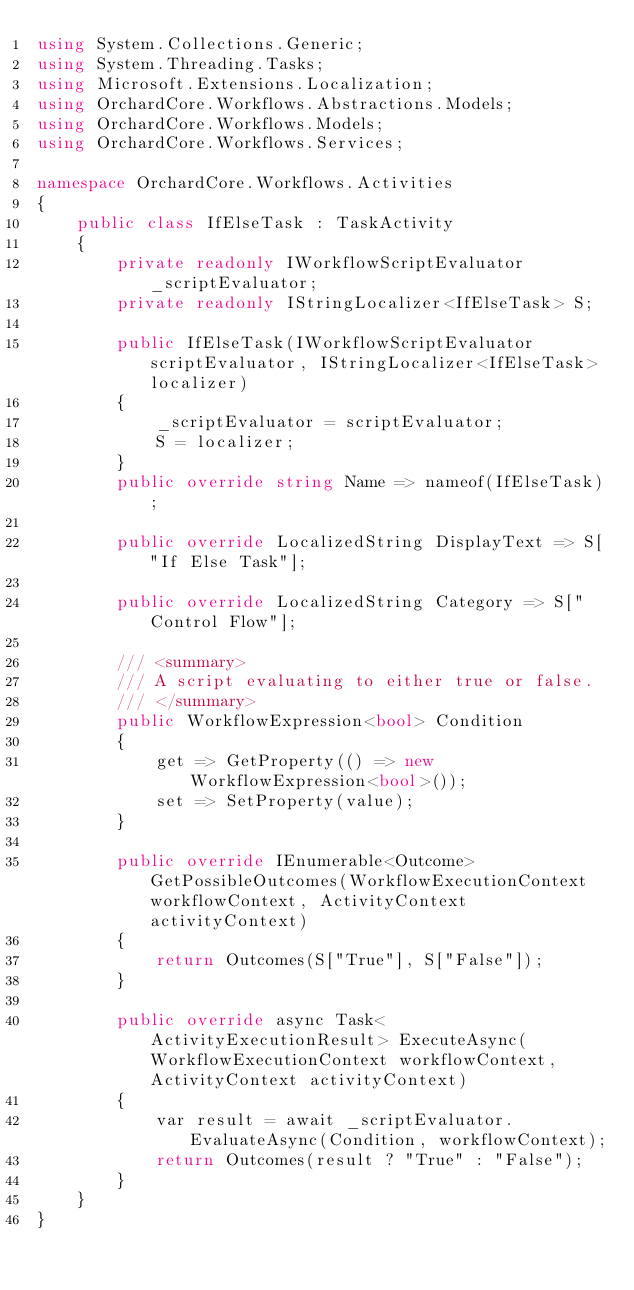Convert code to text. <code><loc_0><loc_0><loc_500><loc_500><_C#_>using System.Collections.Generic;
using System.Threading.Tasks;
using Microsoft.Extensions.Localization;
using OrchardCore.Workflows.Abstractions.Models;
using OrchardCore.Workflows.Models;
using OrchardCore.Workflows.Services;

namespace OrchardCore.Workflows.Activities
{
    public class IfElseTask : TaskActivity
    {
        private readonly IWorkflowScriptEvaluator _scriptEvaluator;
        private readonly IStringLocalizer<IfElseTask> S;

        public IfElseTask(IWorkflowScriptEvaluator scriptEvaluator, IStringLocalizer<IfElseTask> localizer)
        {
            _scriptEvaluator = scriptEvaluator;
            S = localizer;
        }
        public override string Name => nameof(IfElseTask);
        
        public override LocalizedString DisplayText => S["If Else Task"];
        
        public override LocalizedString Category => S["Control Flow"];

        /// <summary>
        /// A script evaluating to either true or false.
        /// </summary>
        public WorkflowExpression<bool> Condition
        {
            get => GetProperty(() => new WorkflowExpression<bool>());
            set => SetProperty(value);
        }

        public override IEnumerable<Outcome> GetPossibleOutcomes(WorkflowExecutionContext workflowContext, ActivityContext activityContext)
        {
            return Outcomes(S["True"], S["False"]);
        }

        public override async Task<ActivityExecutionResult> ExecuteAsync(WorkflowExecutionContext workflowContext, ActivityContext activityContext)
        {
            var result = await _scriptEvaluator.EvaluateAsync(Condition, workflowContext);
            return Outcomes(result ? "True" : "False");
        }
    }
}</code> 